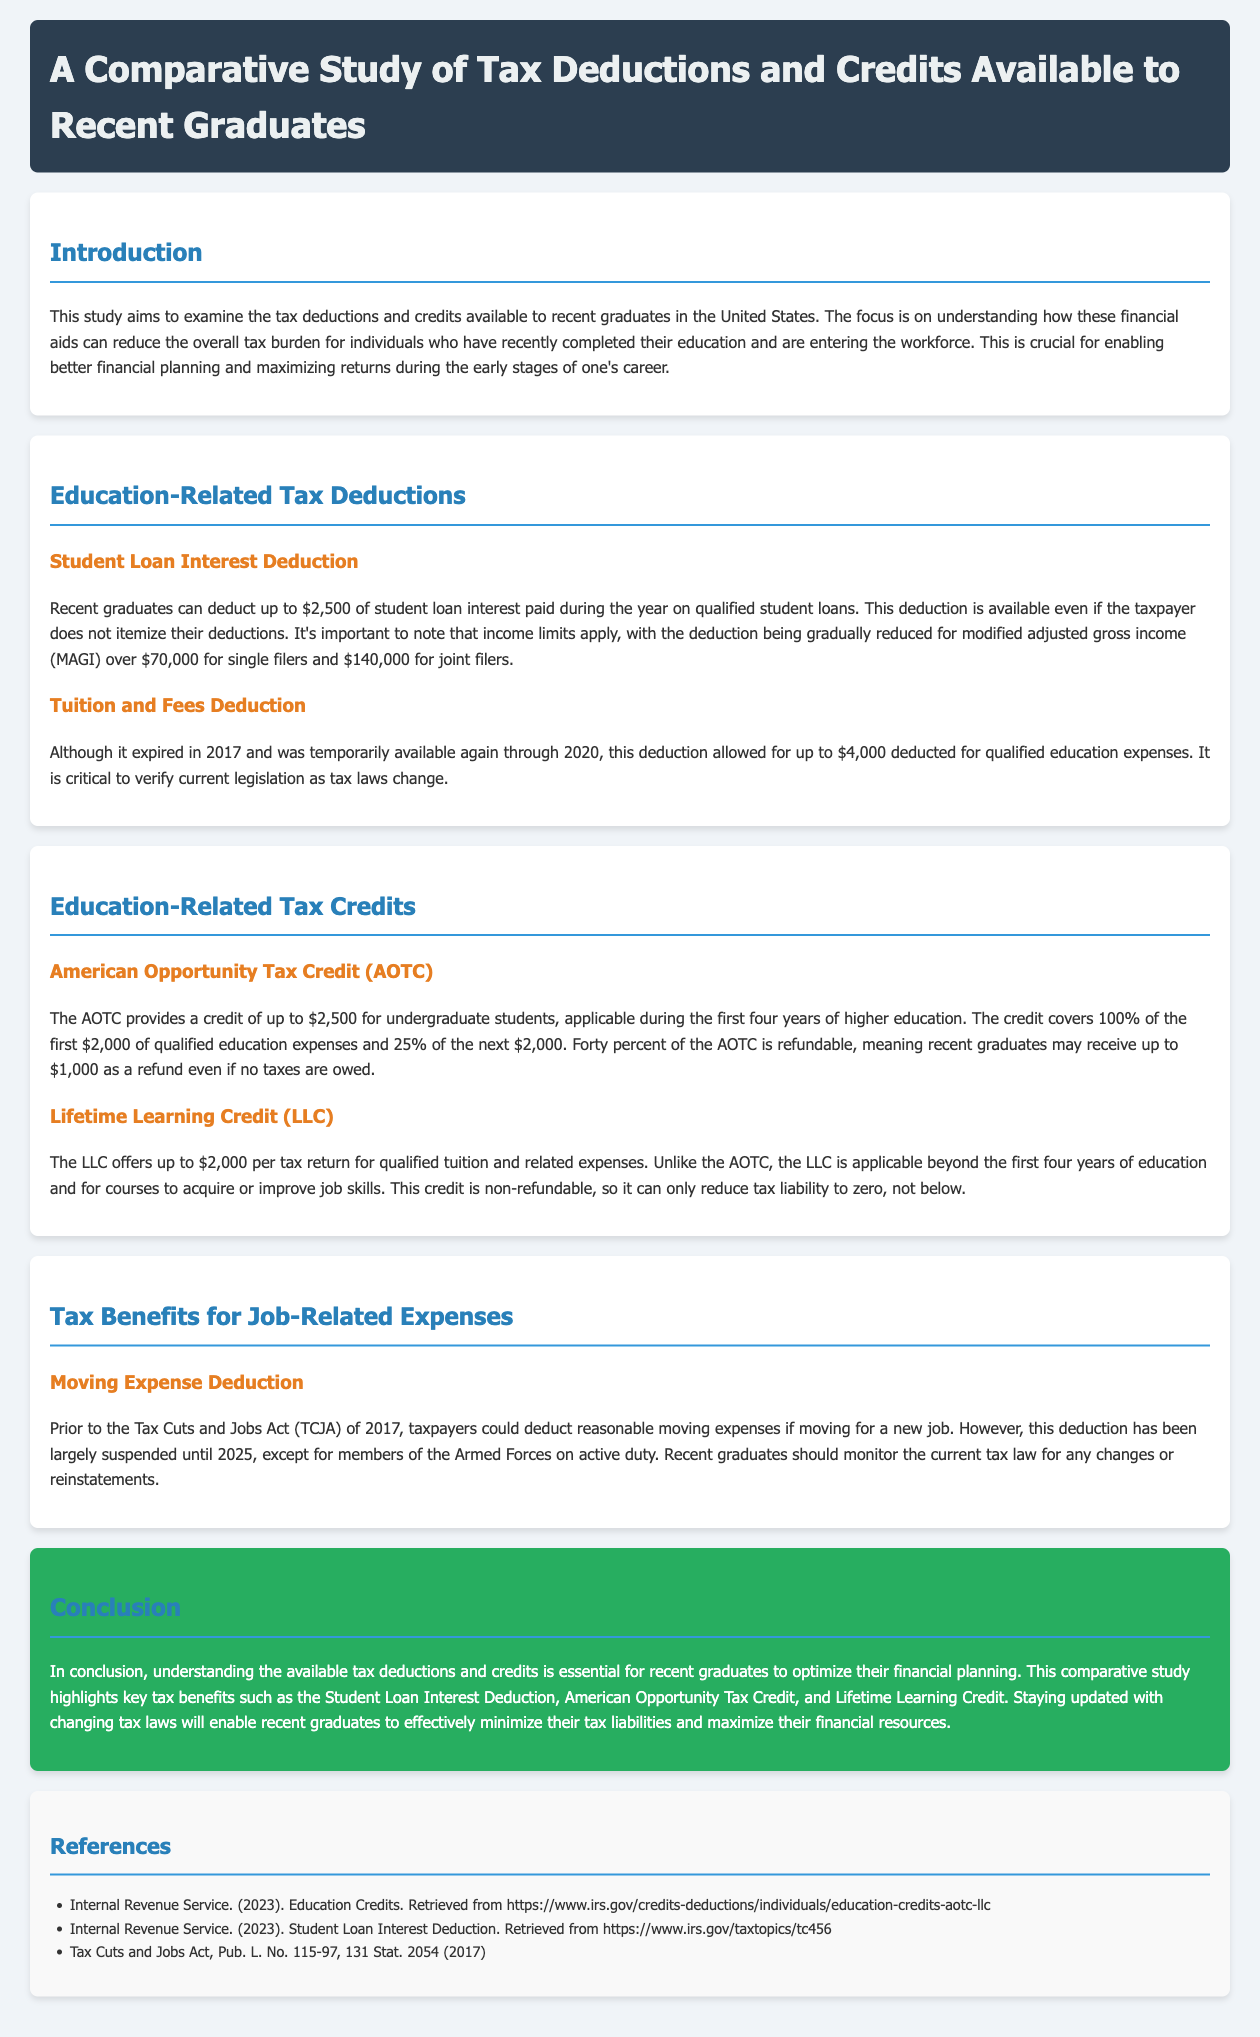What is the main focus of the study? The study focuses on understanding tax deductions and credits available to recent graduates to help reduce their overall tax burden.
Answer: Understanding tax deductions and credits What is the maximum deduction for student loan interest? The document states that recent graduates can deduct up to $2,500 of student loan interest paid during the year.
Answer: $2,500 What is the refundable portion of the American Opportunity Tax Credit? The document specifies that 40% of the AOTC is refundable, which may be received as a refund even if no taxes are owed.
Answer: 40% When did the Tuition and Fees Deduction expire? The document indicates that this deduction expired in 2017.
Answer: 2017 Who can still claim the Moving Expense Deduction? The document mentions that this deduction is still available for members of the Armed Forces on active duty.
Answer: Members of the Armed Forces What is the limit for the Lifetime Learning Credit? According to the document, the LLC offers up to $2,000 per tax return for qualified expenses.
Answer: $2,000 